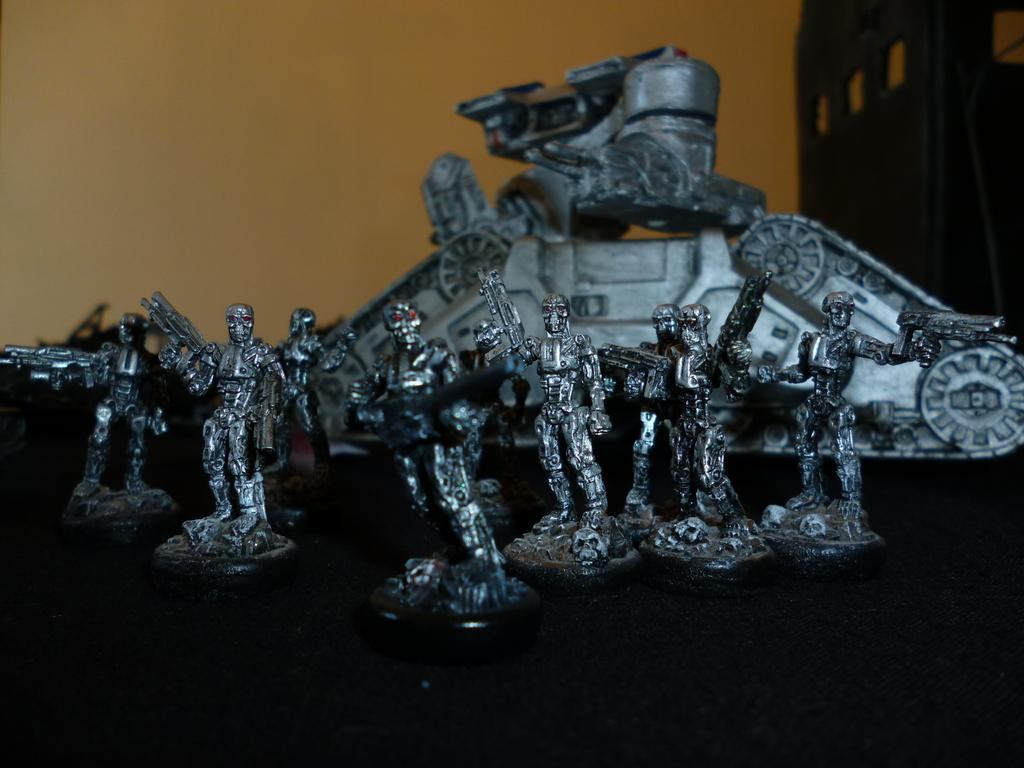What is the main subject in the image? There is a figure in the image. What type of crime is being committed by the figure in the image? There is no indication of any crime being committed in the image; it only shows a figure. 